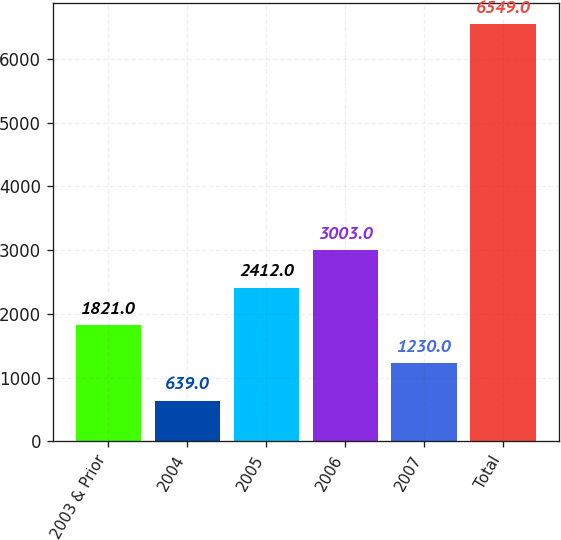Convert chart to OTSL. <chart><loc_0><loc_0><loc_500><loc_500><bar_chart><fcel>2003 & Prior<fcel>2004<fcel>2005<fcel>2006<fcel>2007<fcel>Total<nl><fcel>1821<fcel>639<fcel>2412<fcel>3003<fcel>1230<fcel>6549<nl></chart> 